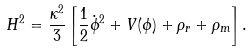<formula> <loc_0><loc_0><loc_500><loc_500>H ^ { 2 } = \frac { \kappa ^ { 2 } } { 3 } \left [ \frac { 1 } { 2 } \dot { \phi } ^ { 2 } + V ( \phi ) + \rho _ { r } + \rho _ { m } \right ] .</formula> 